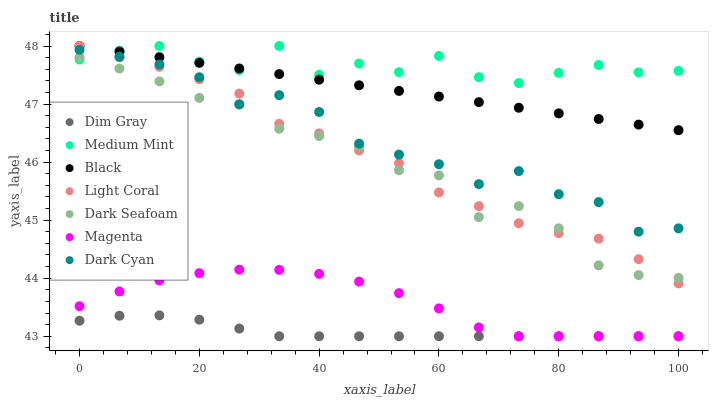Does Dim Gray have the minimum area under the curve?
Answer yes or no. Yes. Does Medium Mint have the maximum area under the curve?
Answer yes or no. Yes. Does Light Coral have the minimum area under the curve?
Answer yes or no. No. Does Light Coral have the maximum area under the curve?
Answer yes or no. No. Is Black the smoothest?
Answer yes or no. Yes. Is Medium Mint the roughest?
Answer yes or no. Yes. Is Dim Gray the smoothest?
Answer yes or no. No. Is Dim Gray the roughest?
Answer yes or no. No. Does Dim Gray have the lowest value?
Answer yes or no. Yes. Does Light Coral have the lowest value?
Answer yes or no. No. Does Black have the highest value?
Answer yes or no. Yes. Does Dim Gray have the highest value?
Answer yes or no. No. Is Magenta less than Medium Mint?
Answer yes or no. Yes. Is Dark Seafoam greater than Magenta?
Answer yes or no. Yes. Does Dim Gray intersect Magenta?
Answer yes or no. Yes. Is Dim Gray less than Magenta?
Answer yes or no. No. Is Dim Gray greater than Magenta?
Answer yes or no. No. Does Magenta intersect Medium Mint?
Answer yes or no. No. 